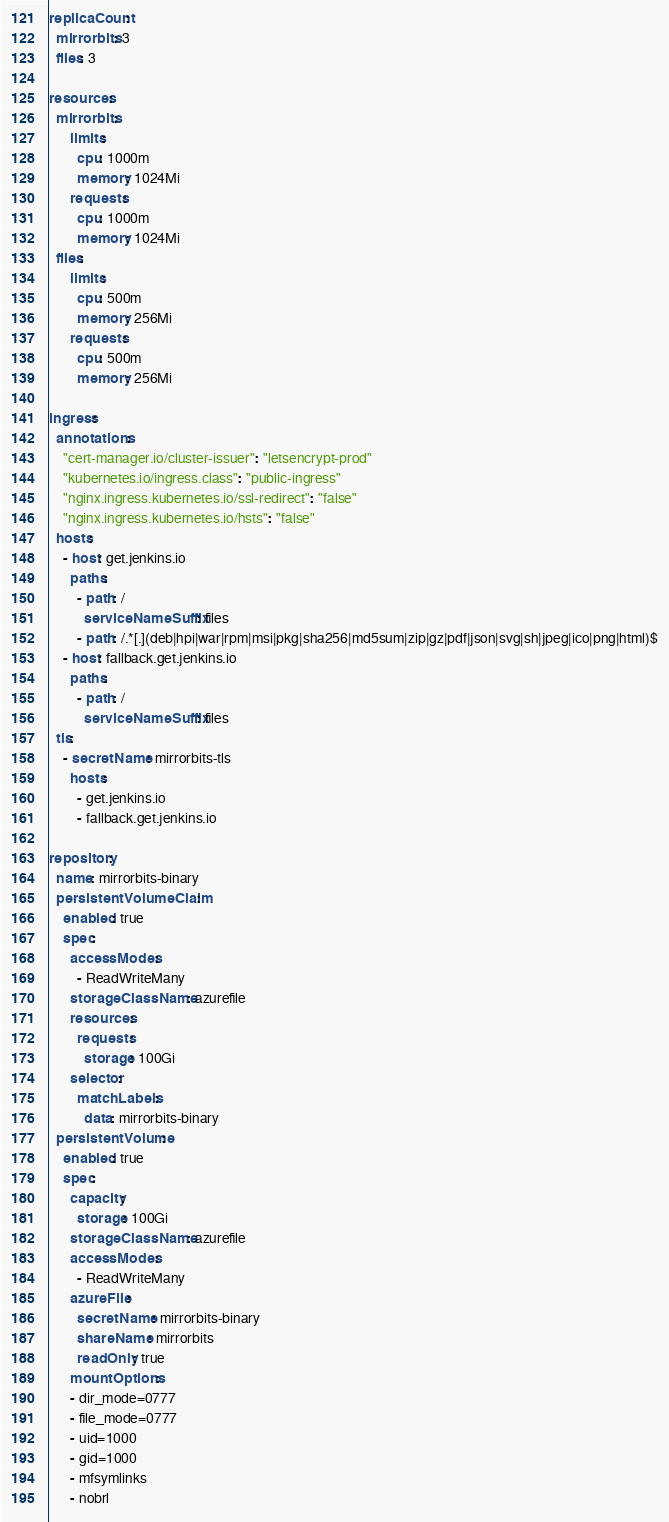<code> <loc_0><loc_0><loc_500><loc_500><_YAML_>replicaCount:
  mirrorbits: 3
  files: 3

resources:
  mirrorbits:
      limits:
        cpu: 1000m
        memory: 1024Mi
      requests:
        cpu: 1000m
        memory: 1024Mi
  files:
      limits:
        cpu: 500m
        memory: 256Mi
      requests:
        cpu: 500m
        memory: 256Mi

ingress:
  annotations:
    "cert-manager.io/cluster-issuer": "letsencrypt-prod"
    "kubernetes.io/ingress.class": "public-ingress"
    "nginx.ingress.kubernetes.io/ssl-redirect": "false"
    "nginx.ingress.kubernetes.io/hsts": "false"
  hosts:
    - host: get.jenkins.io
      paths:
        - path: /
          serviceNameSuffix: files
        - path: /.*[.](deb|hpi|war|rpm|msi|pkg|sha256|md5sum|zip|gz|pdf|json|svg|sh|jpeg|ico|png|html)$
    - host: fallback.get.jenkins.io
      paths:
        - path: /
          serviceNameSuffix: files
  tls:
    - secretName: mirrorbits-tls
      hosts:
        - get.jenkins.io
        - fallback.get.jenkins.io

repository:
  name: mirrorbits-binary
  persistentVolumeClaim:
    enabled: true
    spec:
      accessModes:
        - ReadWriteMany
      storageClassName: azurefile
      resources:
        requests:
          storage: 100Gi
      selector:
        matchLabels:
          data: mirrorbits-binary
  persistentVolume:
    enabled: true
    spec:
      capacity:
        storage: 100Gi
      storageClassName: azurefile
      accessModes:
        - ReadWriteMany
      azureFile:
        secretName: mirrorbits-binary
        shareName: mirrorbits
        readOnly: true
      mountOptions:
      - dir_mode=0777
      - file_mode=0777
      - uid=1000
      - gid=1000
      - mfsymlinks
      - nobrl
</code> 